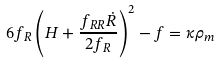<formula> <loc_0><loc_0><loc_500><loc_500>6 f _ { R } \left ( H + \frac { f _ { R R } \dot { R } } { 2 f _ { R } } \right ) ^ { 2 } - f = \kappa \rho _ { m } \,</formula> 